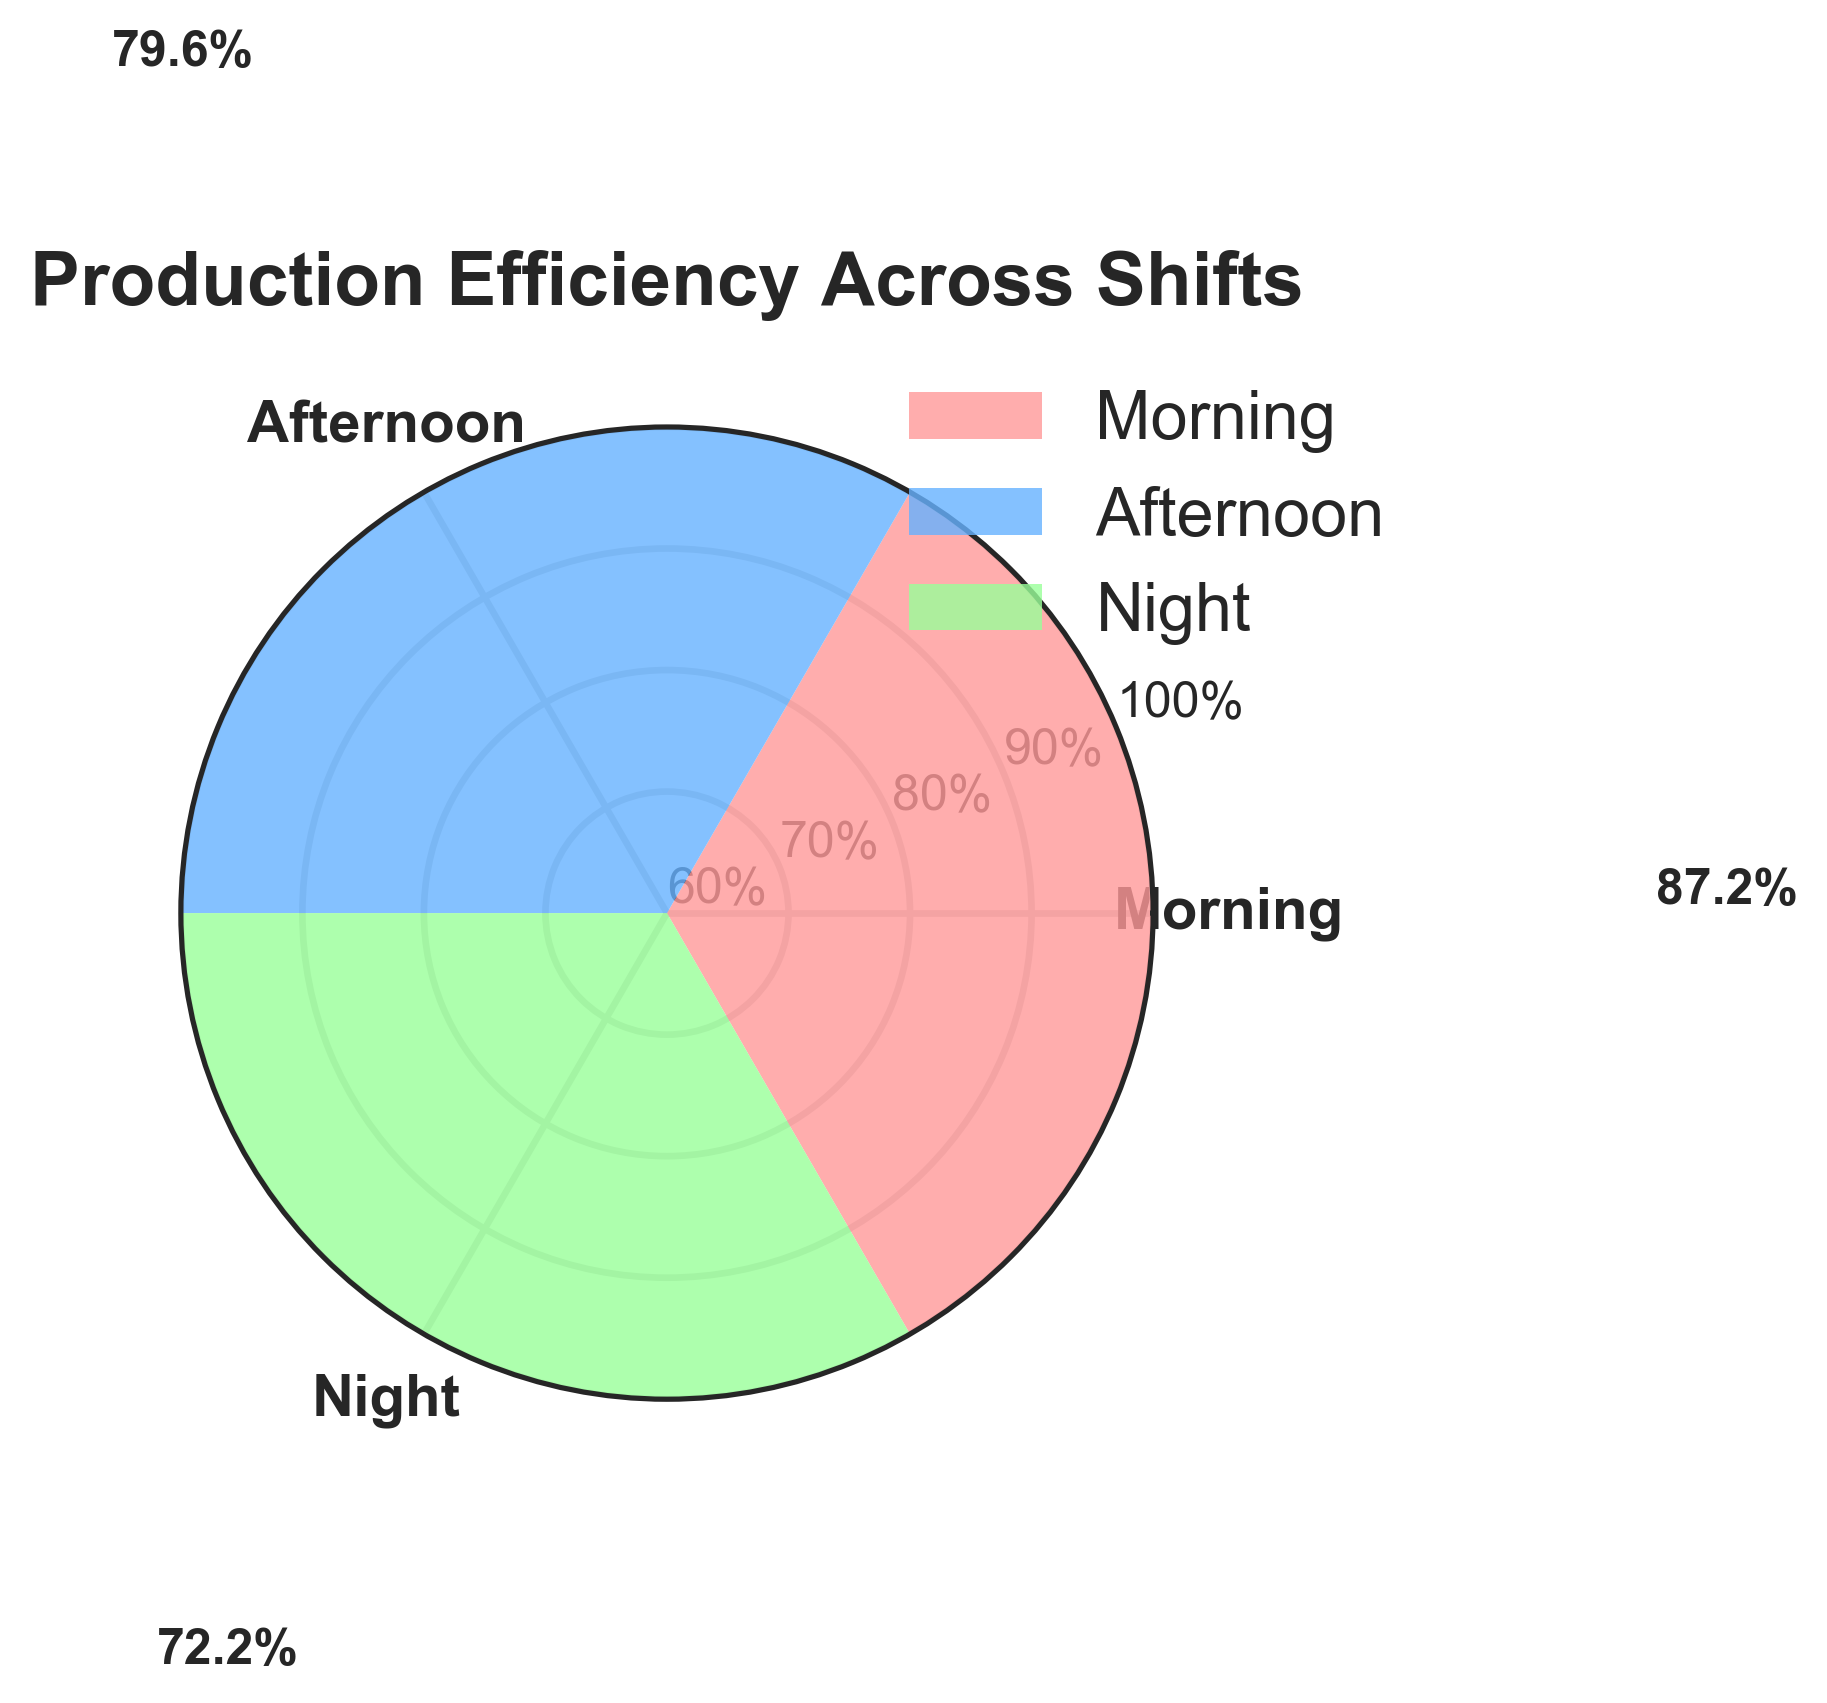What's the title of this chart? The title of the chart is written prominently at the top, which indicates the main focus of the chart.
Answer: Production Efficiency Across Shifts What are the three shifts illustrated in the chart? The names of the shifts are indicated on the radial axes of the plot.
Answer: Morning, Afternoon, Night What is the efficiency percentage for the Night shift? The efficiency percentage for each shift is labeled beside the corresponding bar. Look at the bar corresponding to the Night shift and read the value.
Answer: 72.2% Which shift has the highest efficiency percentage? Compare the numerical values labeled on top of each bar; the highest value represents the highest efficiency.
Answer: Morning What is the average efficiency percentage for the Morning shift? The efficiency percentage for the Morning shift bars is shown. The values used to calculate the mean (85, 90, 87, 88, 86) are already processed in the plot.
Answer: 87.2% By how much does the Afternoon shift's efficiency percentage differ from the Morning shift? Subtract the average efficiency percentage of the Afternoon shift from the average efficiency percentage of the Morning shift.
Answer: 6.6% Which shift has the lowest overall efficiency percentage, and what is that percentage? Identify the shift with the smallest labeled bar value.
Answer: Night, 72.2% How does the efficiency percentage for the Afternoon shift compare to that of the Night shift? The Afternoon shift's efficiency percentage is directly compared to that of the Night shift numerically.
Answer: Afternoon is higher by 5.0% What range of efficiency percentages is observed for these shifts? Identify the minimum and maximum percentages among the labeled values. Range = maximum - minimum.
Answer: 15% (87.2% - 72.2%) 